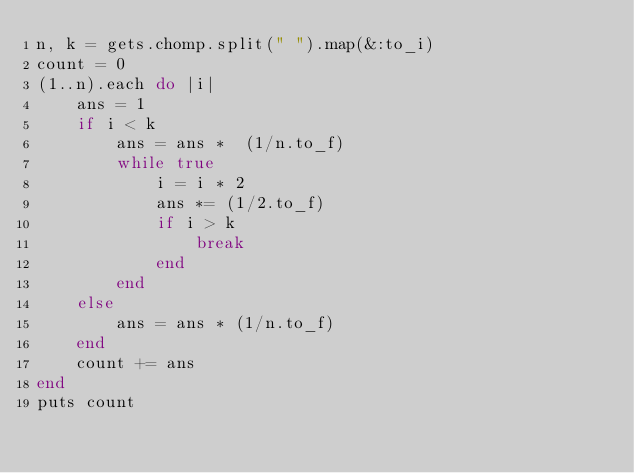Convert code to text. <code><loc_0><loc_0><loc_500><loc_500><_Ruby_>n, k = gets.chomp.split(" ").map(&:to_i)
count = 0
(1..n).each do |i|
    ans = 1
    if i < k
        ans = ans *  (1/n.to_f)
        while true
            i = i * 2
            ans *= (1/2.to_f)
            if i > k
                break
            end
        end
    else
        ans = ans * (1/n.to_f)
    end
    count += ans
end
puts count</code> 